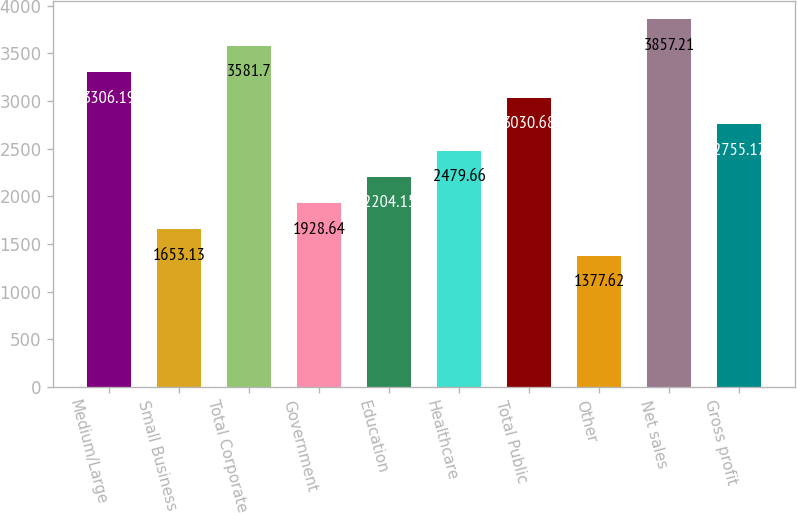Convert chart. <chart><loc_0><loc_0><loc_500><loc_500><bar_chart><fcel>Medium/Large<fcel>Small Business<fcel>Total Corporate<fcel>Government<fcel>Education<fcel>Healthcare<fcel>Total Public<fcel>Other<fcel>Net sales<fcel>Gross profit<nl><fcel>3306.19<fcel>1653.13<fcel>3581.7<fcel>1928.64<fcel>2204.15<fcel>2479.66<fcel>3030.68<fcel>1377.62<fcel>3857.21<fcel>2755.17<nl></chart> 